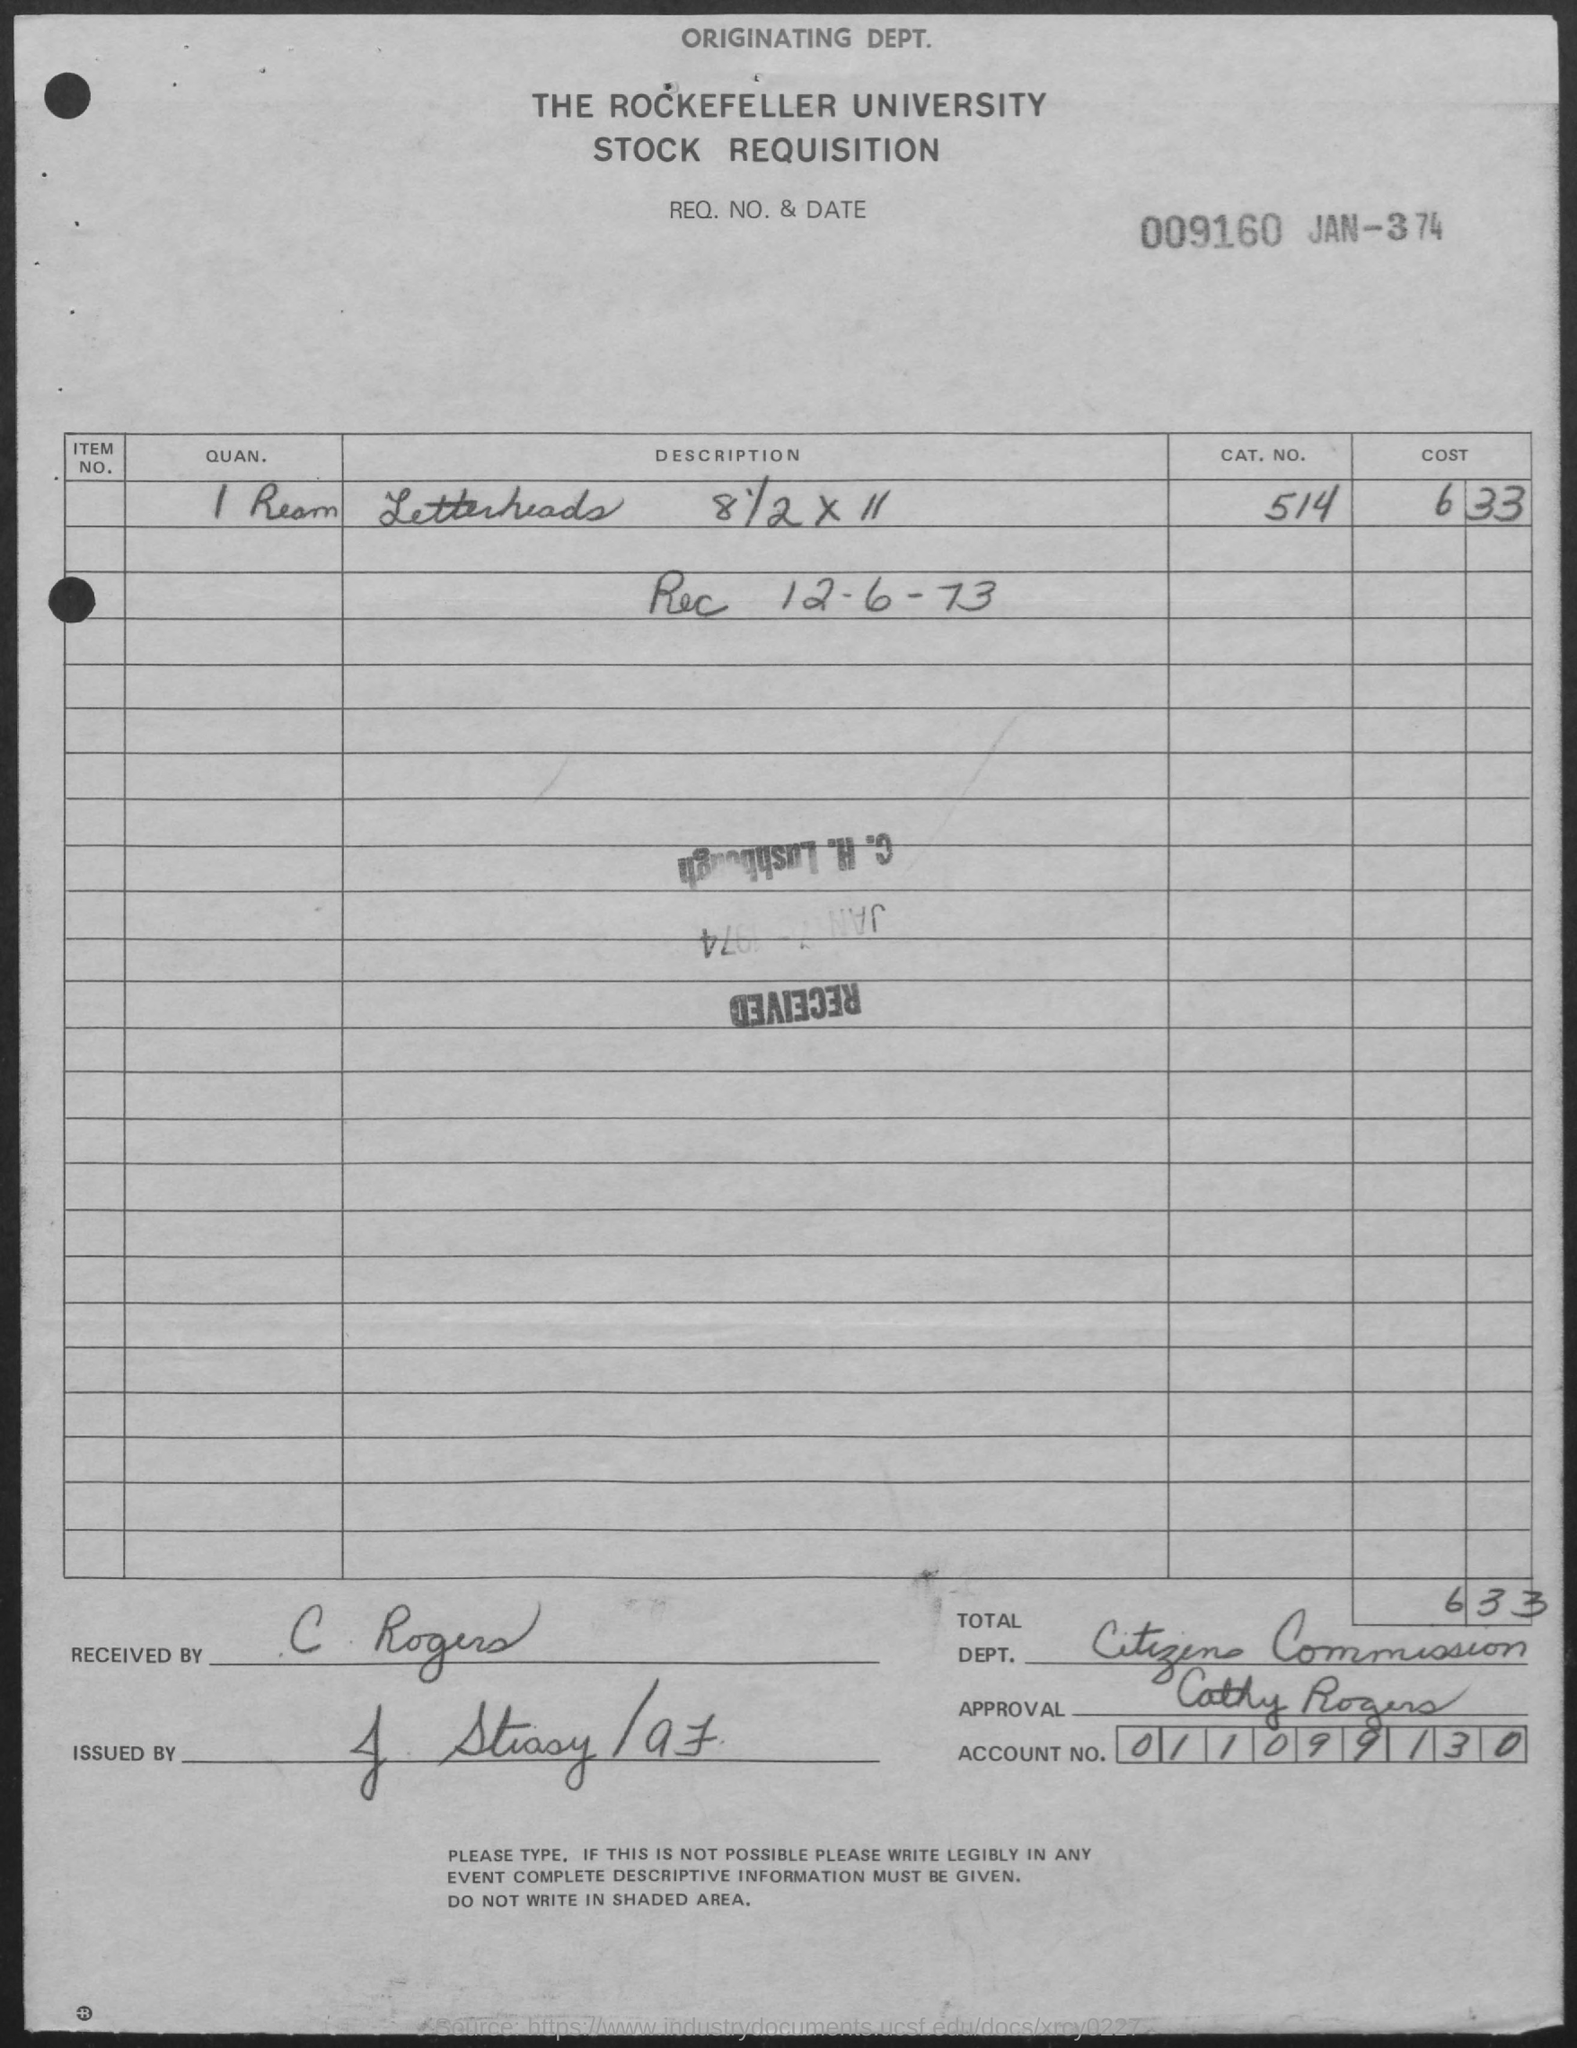Outline some significant characteristics in this image. The Rockefeller University is the name of the university mentioned in the given letter. What is the CAT.NO. mentioned in the given page? 514. The letter was received by C. Rogers. The cost of letterheads, as mentioned on the given page, is 6.33. The quantity of letterheads mentioned in the given page is 1 Ream. 